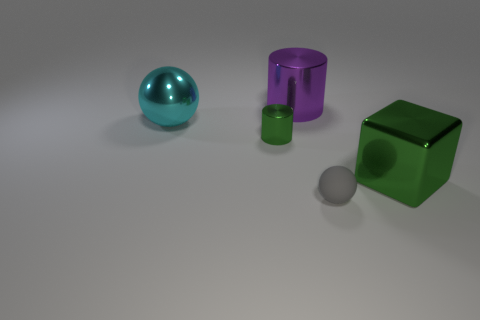Is there anything else that has the same material as the gray object?
Offer a very short reply. No. How many other things are the same shape as the tiny gray object?
Offer a terse response. 1. There is a small object that is left of the small ball; does it have the same color as the block?
Your answer should be very brief. Yes. Is there another ball of the same color as the tiny sphere?
Offer a very short reply. No. There is a large cylinder; how many green objects are on the left side of it?
Your answer should be very brief. 1. How many other things are there of the same size as the purple shiny object?
Provide a short and direct response. 2. Does the large object that is in front of the big metal ball have the same material as the tiny object behind the gray rubber object?
Provide a short and direct response. Yes. There is a metallic cylinder that is the same size as the cube; what is its color?
Provide a succinct answer. Purple. Is there any other thing that has the same color as the tiny rubber sphere?
Provide a short and direct response. No. What size is the green thing to the right of the green thing that is behind the big shiny thing that is to the right of the large purple thing?
Offer a terse response. Large. 